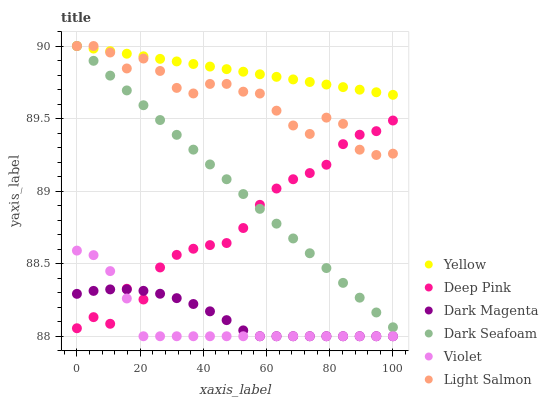Does Violet have the minimum area under the curve?
Answer yes or no. Yes. Does Yellow have the maximum area under the curve?
Answer yes or no. Yes. Does Deep Pink have the minimum area under the curve?
Answer yes or no. No. Does Deep Pink have the maximum area under the curve?
Answer yes or no. No. Is Dark Seafoam the smoothest?
Answer yes or no. Yes. Is Deep Pink the roughest?
Answer yes or no. Yes. Is Dark Magenta the smoothest?
Answer yes or no. No. Is Dark Magenta the roughest?
Answer yes or no. No. Does Dark Magenta have the lowest value?
Answer yes or no. Yes. Does Deep Pink have the lowest value?
Answer yes or no. No. Does Dark Seafoam have the highest value?
Answer yes or no. Yes. Does Deep Pink have the highest value?
Answer yes or no. No. Is Violet less than Dark Seafoam?
Answer yes or no. Yes. Is Yellow greater than Dark Magenta?
Answer yes or no. Yes. Does Dark Magenta intersect Violet?
Answer yes or no. Yes. Is Dark Magenta less than Violet?
Answer yes or no. No. Is Dark Magenta greater than Violet?
Answer yes or no. No. Does Violet intersect Dark Seafoam?
Answer yes or no. No. 